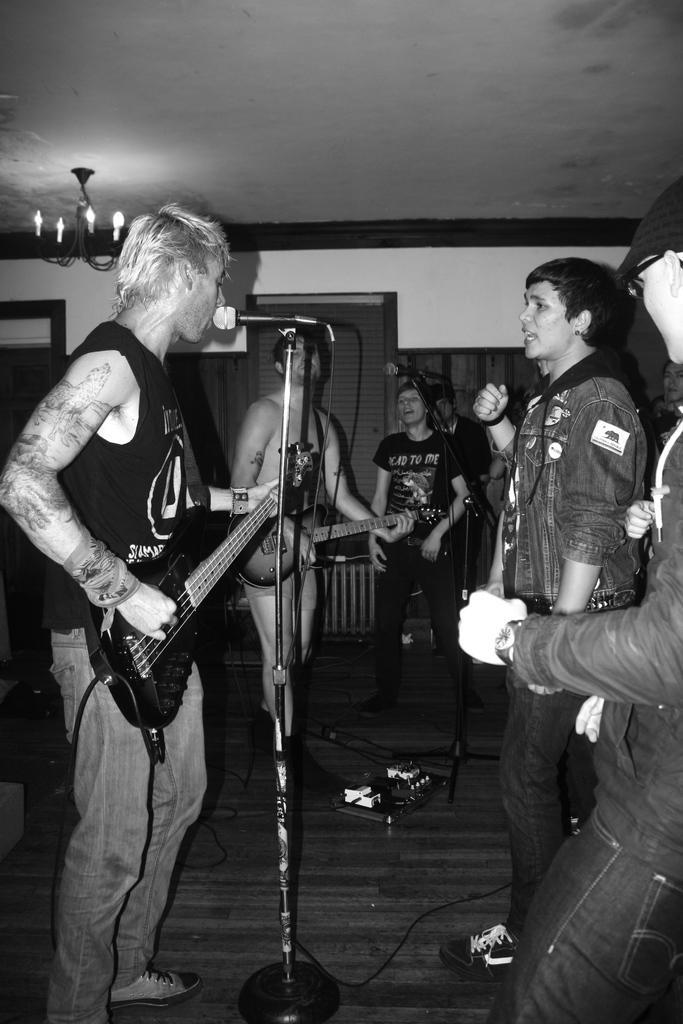How would you summarize this image in a sentence or two? It is a picture in the picture there are few men,they are singing the songs, the first two men to the left side are playing the guitar, in the background there are windows door and a wall. 